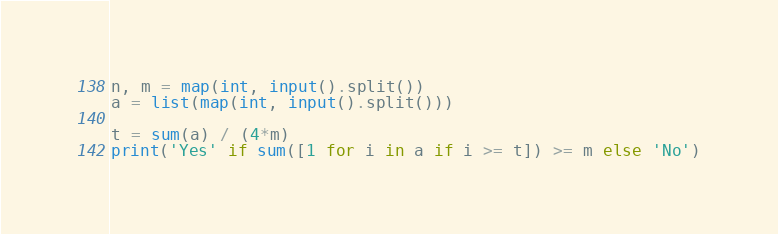Convert code to text. <code><loc_0><loc_0><loc_500><loc_500><_Python_>n, m = map(int, input().split())
a = list(map(int, input().split()))

t = sum(a) / (4*m)
print('Yes' if sum([1 for i in a if i >= t]) >= m else 'No')</code> 